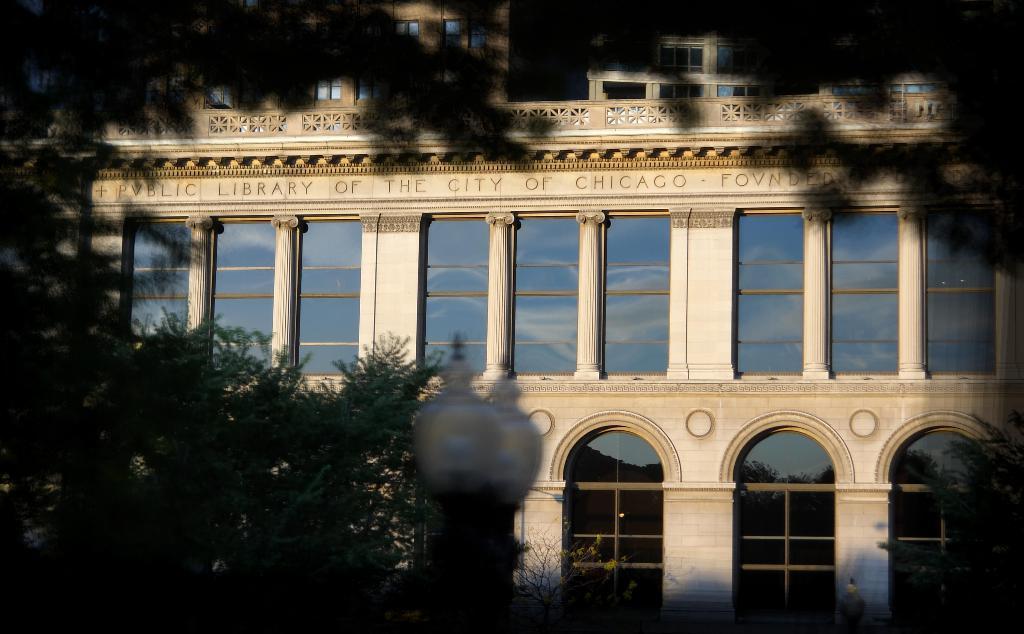In one or two sentences, can you explain what this image depicts? In this image I can see trees, white colour building, few lights and over here I can see something is written. I can also see few windows. 